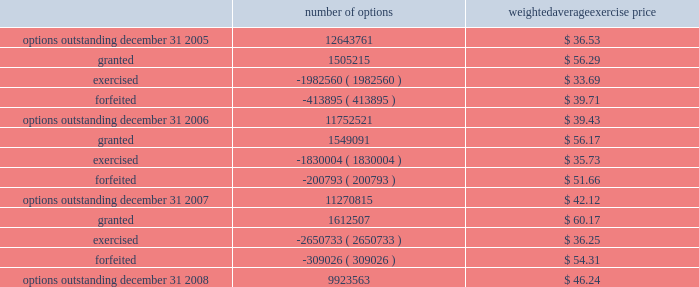N o t e s t o c o n s o l i d a t e d f i n a n c i a l s t a t e m e n t s ( continued ) ace limited and subsidiaries the table shows changes in the company 2019s stock options for the years ended december 31 , 2008 , 2007 , and number of options weighted average exercise price .
The weighted-average remaining contractual term was 5.8 years for the stock options outstanding and 4.6 years for the stock options exercisable at december 31 , 2008 .
The total intrinsic value was approximately $ 66 million for stock options out- standing and $ 81 million for stock options exercisable at december 31 , 2008 .
The weighted-average fair value for the stock options granted for the year ended december 31 , 2008 was $ 17.60 .
The total intrinsic value for stock options exercised dur- ing the years ended december 31 , 2008 , 2007 , and 2006 , was approximately $ 54 million , $ 44 million , and $ 43 million , respectively .
The amount of cash received during the year ended december 31 , 2008 , from the exercise of stock options was $ 97 million .
Restricted stock the company 2019s 2004 ltip also provides for grants of restricted stock .
The company generally grants restricted stock with a 4-year vesting period , based on a graded vesting schedule .
The restricted stock is granted at market close price on the date of grant .
Included in the company 2019s share-based compensation expense in the year ended december 31 , 2008 , is a portion of the cost related to the unvested restricted stock granted in the years 2004 to 2008. .
What is the growth rate of the weighted average exercise price of options from december 31 , 2005 to december 31 , 2008? 
Computations: ((46.24 - 36.53) / 36.53)
Answer: 0.26581. 